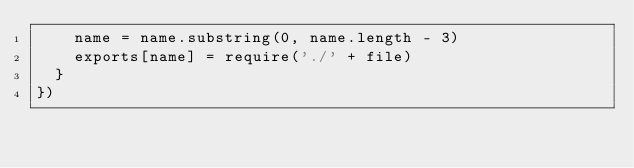Convert code to text. <code><loc_0><loc_0><loc_500><loc_500><_JavaScript_>    name = name.substring(0, name.length - 3)
    exports[name] = require('./' + file)
  }
})
</code> 